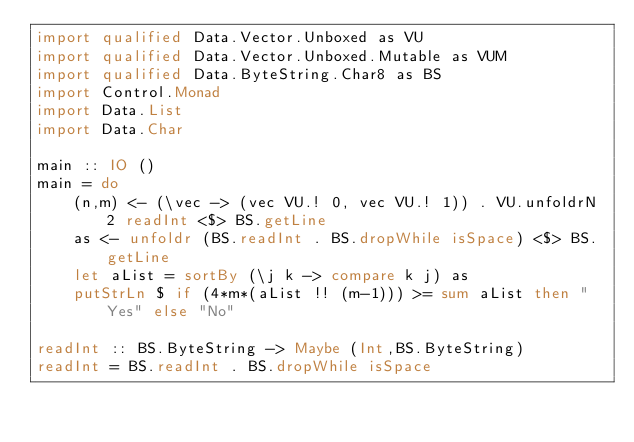<code> <loc_0><loc_0><loc_500><loc_500><_Haskell_>import qualified Data.Vector.Unboxed as VU
import qualified Data.Vector.Unboxed.Mutable as VUM
import qualified Data.ByteString.Char8 as BS
import Control.Monad
import Data.List
import Data.Char

main :: IO ()
main = do
    (n,m) <- (\vec -> (vec VU.! 0, vec VU.! 1)) . VU.unfoldrN 2 readInt <$> BS.getLine
    as <- unfoldr (BS.readInt . BS.dropWhile isSpace) <$> BS.getLine
    let aList = sortBy (\j k -> compare k j) as
    putStrLn $ if (4*m*(aList !! (m-1))) >= sum aList then "Yes" else "No"

readInt :: BS.ByteString -> Maybe (Int,BS.ByteString)
readInt = BS.readInt . BS.dropWhile isSpace</code> 